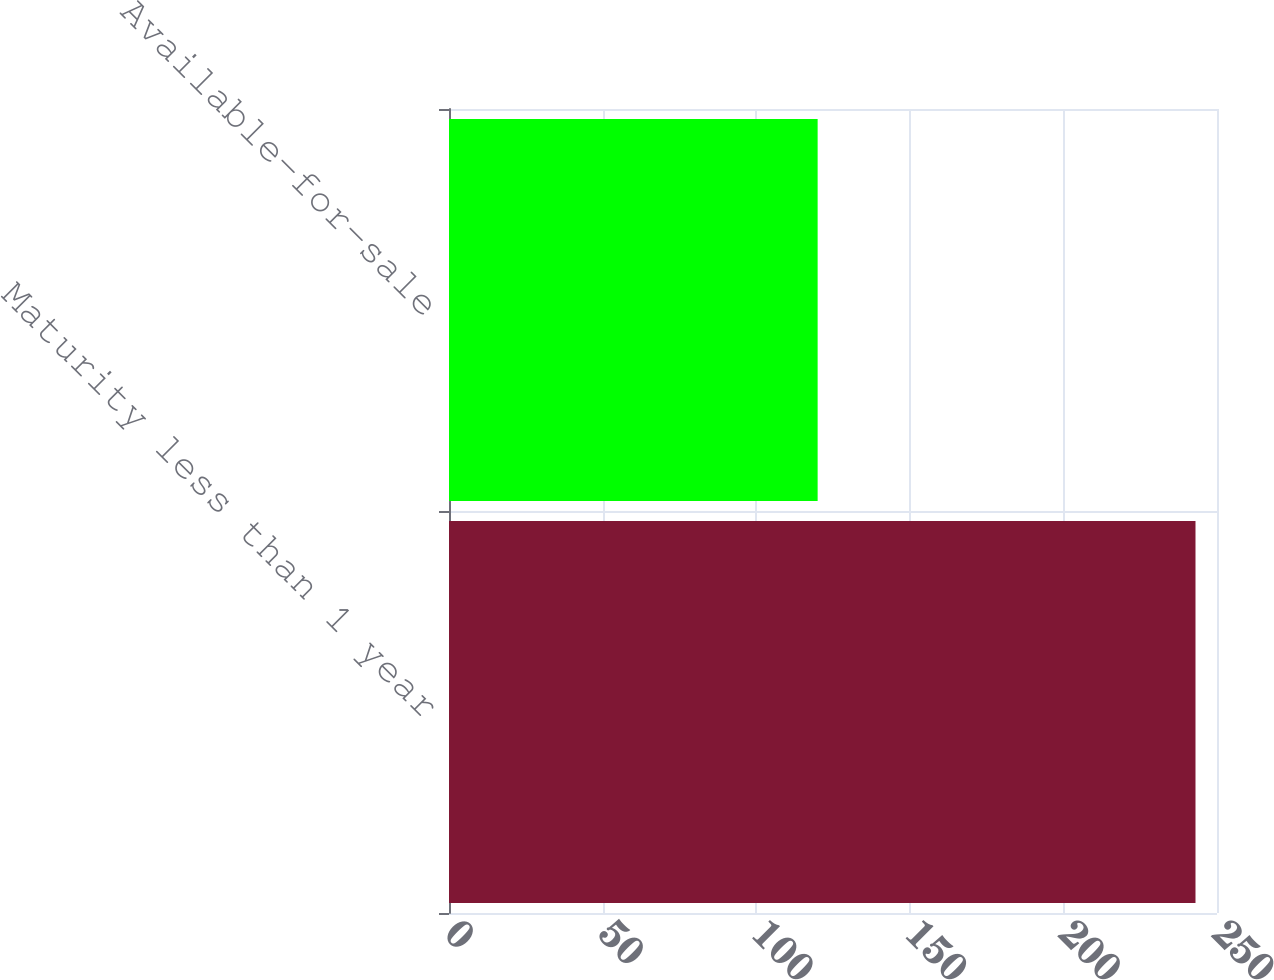Convert chart. <chart><loc_0><loc_0><loc_500><loc_500><bar_chart><fcel>Maturity less than 1 year<fcel>Available-for-sale<nl><fcel>243<fcel>120<nl></chart> 